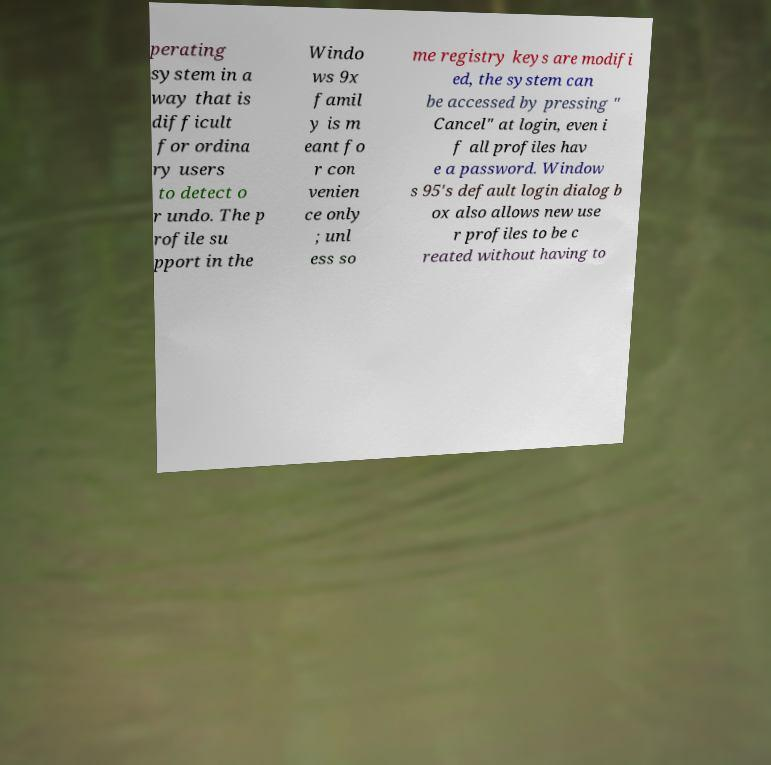What messages or text are displayed in this image? I need them in a readable, typed format. perating system in a way that is difficult for ordina ry users to detect o r undo. The p rofile su pport in the Windo ws 9x famil y is m eant fo r con venien ce only ; unl ess so me registry keys are modifi ed, the system can be accessed by pressing " Cancel" at login, even i f all profiles hav e a password. Window s 95's default login dialog b ox also allows new use r profiles to be c reated without having to 